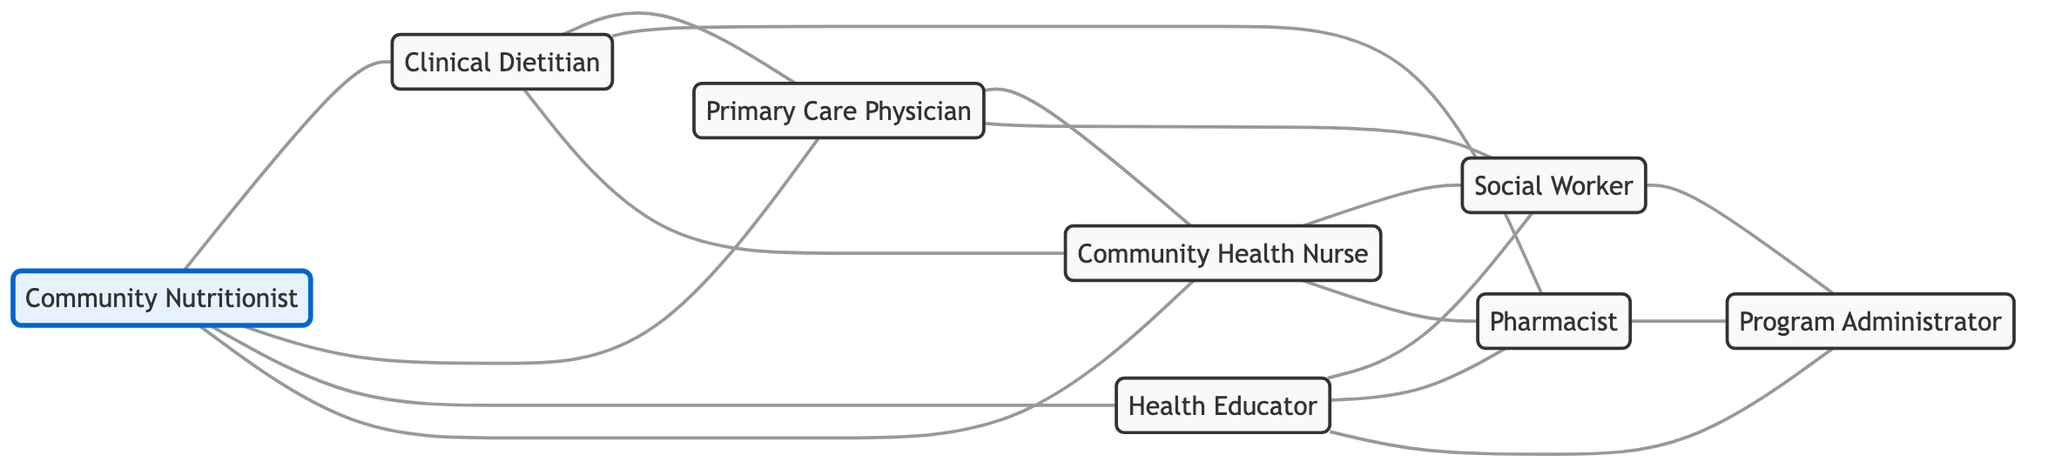What is the total number of nodes in the diagram? The diagram lists individual healthcare professionals, bringing the total to 8 nodes.
Answer: 8 Who is connected to the Community Nutritionist? The Community Nutritionist is connected to four other professionals: Clinical Dietitian, Primary Care Physician, Health Educator, and Community Health Nurse.
Answer: Clinical Dietitian, Primary Care Physician, Health Educator, Community Health Nurse How many edges are there in the graph? The diagram includes multiple connections (edges) among nodes, resulting in a total of 15 edges.
Answer: 15 Which node has the highest number of connections? By counting the edges, the Community Health Nurse connects to five other professionals, making it the most connected node in the network.
Answer: Community Health Nurse What is the relationship between the Clinical Dietitian and the Social Worker? There is no direct edge connecting them, indicating they do not collaborate directly in the network.
Answer: None What is the role of the node that connects to both the Health Educator and the Administrator? The node connecting to both is the Program Administrator, indicating their supervisory or managerial role in the nutritional program.
Answer: Program Administrator How many connections does the Primary Care Physician have? Counting the edges shows that the Primary Care Physician connects to four other professionals, indicating their active role in collaboration.
Answer: 4 Are the pharmacist and the nurse directly connected? Yes, the diagram shows a direct edge between the Pharmacist and Community Health Nurse, indicating collaboration.
Answer: Yes What is the type of the diagram used in this representation? The diagram is an undirected graph, meaning that the relationships between nodes do not have a specific direction.
Answer: Undirected Graph 